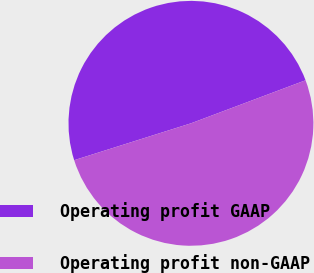Convert chart. <chart><loc_0><loc_0><loc_500><loc_500><pie_chart><fcel>Operating profit GAAP<fcel>Operating profit non-GAAP<nl><fcel>49.15%<fcel>50.85%<nl></chart> 